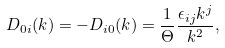Convert formula to latex. <formula><loc_0><loc_0><loc_500><loc_500>D _ { 0 i } ( k ) = - D _ { i 0 } ( k ) = \frac { 1 } { \Theta } \frac { \epsilon _ { i j } k ^ { j } } { { k } ^ { 2 } } ,</formula> 